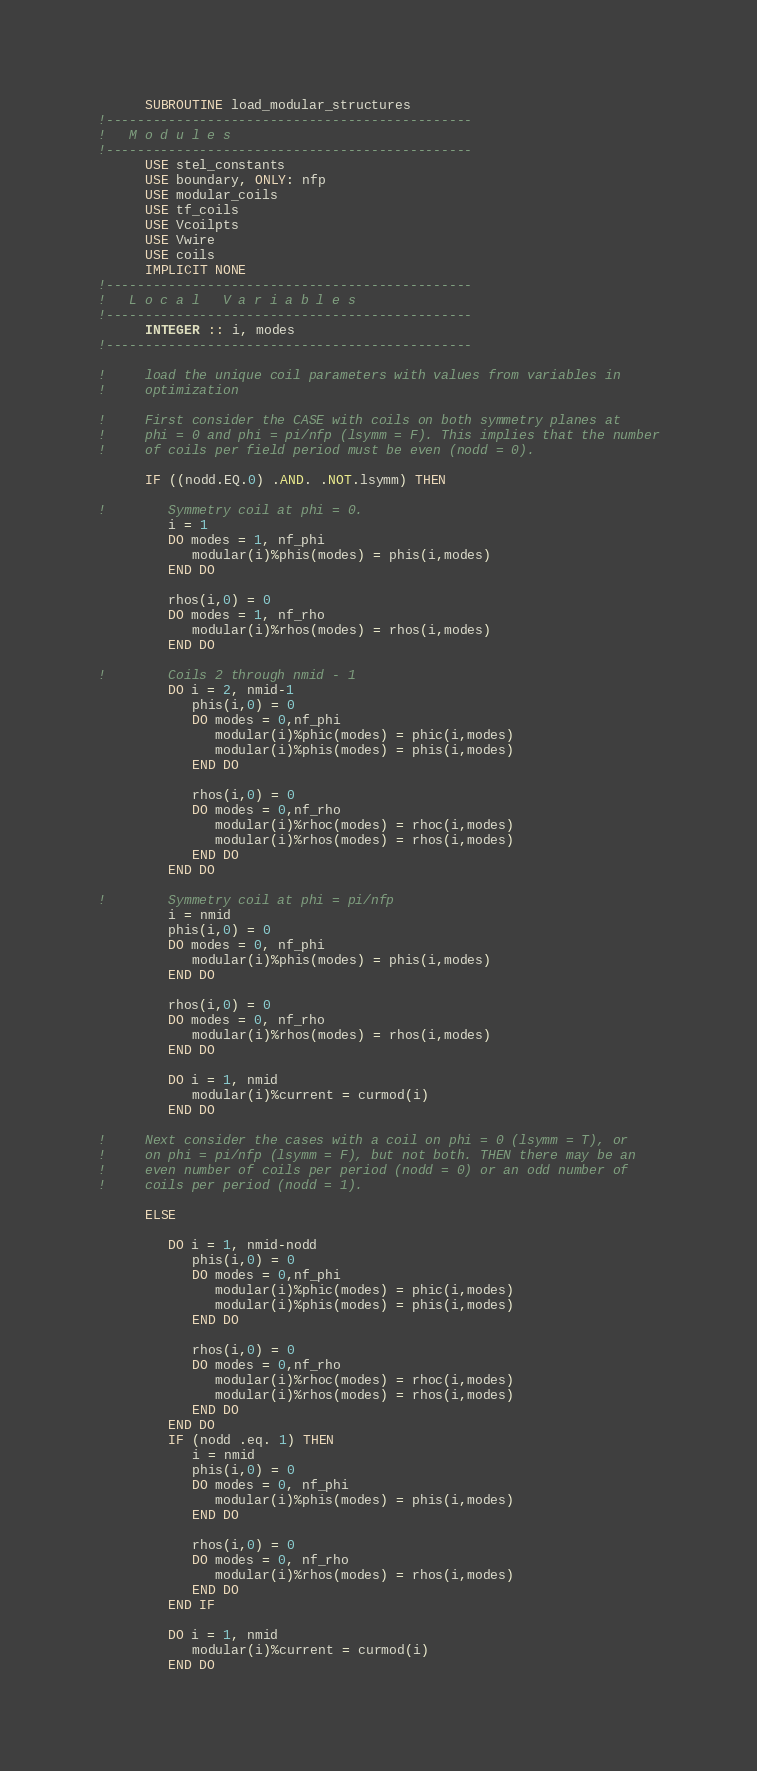<code> <loc_0><loc_0><loc_500><loc_500><_FORTRAN_>      SUBROUTINE load_modular_structures
!-----------------------------------------------
!   M o d u l e s
!-----------------------------------------------
      USE stel_constants
      USE boundary, ONLY: nfp
      USE modular_coils
      USE tf_coils
      USE Vcoilpts
      USE Vwire
      USE coils
      IMPLICIT NONE
!-----------------------------------------------
!   L o c a l   V a r i a b l e s
!-----------------------------------------------
      INTEGER :: i, modes
!-----------------------------------------------

!     load the unique coil parameters with values from variables in
!     optimization

!     First consider the CASE with coils on both symmetry planes at
!     phi = 0 and phi = pi/nfp (lsymm = F). This implies that the number
!     of coils per field period must be even (nodd = 0).

      IF ((nodd.EQ.0) .AND. .NOT.lsymm) THEN

!        Symmetry coil at phi = 0.
         i = 1
         DO modes = 1, nf_phi
            modular(i)%phis(modes) = phis(i,modes)
         END DO

         rhos(i,0) = 0
         DO modes = 1, nf_rho
            modular(i)%rhos(modes) = rhos(i,modes)
         END DO

!        Coils 2 through nmid - 1
         DO i = 2, nmid-1
            phis(i,0) = 0
            DO modes = 0,nf_phi
               modular(i)%phic(modes) = phic(i,modes)
               modular(i)%phis(modes) = phis(i,modes)
            END DO

            rhos(i,0) = 0
            DO modes = 0,nf_rho
               modular(i)%rhoc(modes) = rhoc(i,modes)
               modular(i)%rhos(modes) = rhos(i,modes)
            END DO
         END DO

!        Symmetry coil at phi = pi/nfp
         i = nmid
         phis(i,0) = 0
         DO modes = 0, nf_phi
            modular(i)%phis(modes) = phis(i,modes)
         END DO

         rhos(i,0) = 0
         DO modes = 0, nf_rho
            modular(i)%rhos(modes) = rhos(i,modes)
         END DO

         DO i = 1, nmid
            modular(i)%current = curmod(i)
         END DO

!     Next consider the cases with a coil on phi = 0 (lsymm = T), or
!     on phi = pi/nfp (lsymm = F), but not both. THEN there may be an
!     even number of coils per period (nodd = 0) or an odd number of
!     coils per period (nodd = 1).

      ELSE

         DO i = 1, nmid-nodd
            phis(i,0) = 0
            DO modes = 0,nf_phi
               modular(i)%phic(modes) = phic(i,modes)
               modular(i)%phis(modes) = phis(i,modes)
            END DO

            rhos(i,0) = 0
            DO modes = 0,nf_rho
               modular(i)%rhoc(modes) = rhoc(i,modes)
               modular(i)%rhos(modes) = rhos(i,modes)
            END DO
         END DO
         IF (nodd .eq. 1) THEN
            i = nmid
            phis(i,0) = 0
            DO modes = 0, nf_phi
               modular(i)%phis(modes) = phis(i,modes)
            END DO

            rhos(i,0) = 0
            DO modes = 0, nf_rho
               modular(i)%rhos(modes) = rhos(i,modes)
            END DO
         END IF

         DO i = 1, nmid
            modular(i)%current = curmod(i)
         END DO
</code> 